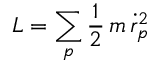Convert formula to latex. <formula><loc_0><loc_0><loc_500><loc_500>L = \sum _ { p } \frac { 1 } { 2 } \, m \, \dot { r } _ { p } ^ { 2 }</formula> 